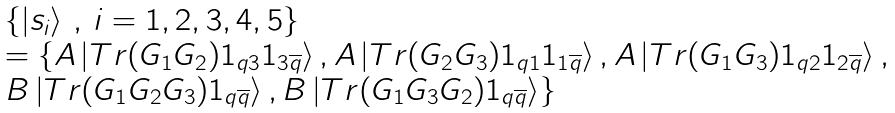<formula> <loc_0><loc_0><loc_500><loc_500>\begin{array} { l } \{ \left | s _ { i } \right \rangle \, , \, i = 1 , 2 , 3 , 4 , 5 \} \\ = \{ A \left | T r ( G _ { 1 } G _ { 2 } ) 1 _ { q 3 } 1 _ { 3 \overline { q } } \right \rangle , A \left | T r ( G _ { 2 } G _ { 3 } ) 1 _ { q 1 } 1 _ { 1 \overline { q } } \right \rangle , A \left | T r ( G _ { 1 } G _ { 3 } ) 1 _ { q 2 } 1 _ { 2 \overline { q } } \right \rangle , \\ B \left | T r ( G _ { 1 } G _ { 2 } G _ { 3 } ) 1 _ { q \overline { q } } \right \rangle , B \left | T r ( G _ { 1 } G _ { 3 } G _ { 2 } ) 1 _ { q \overline { q } } \right \rangle \} \end{array}</formula> 